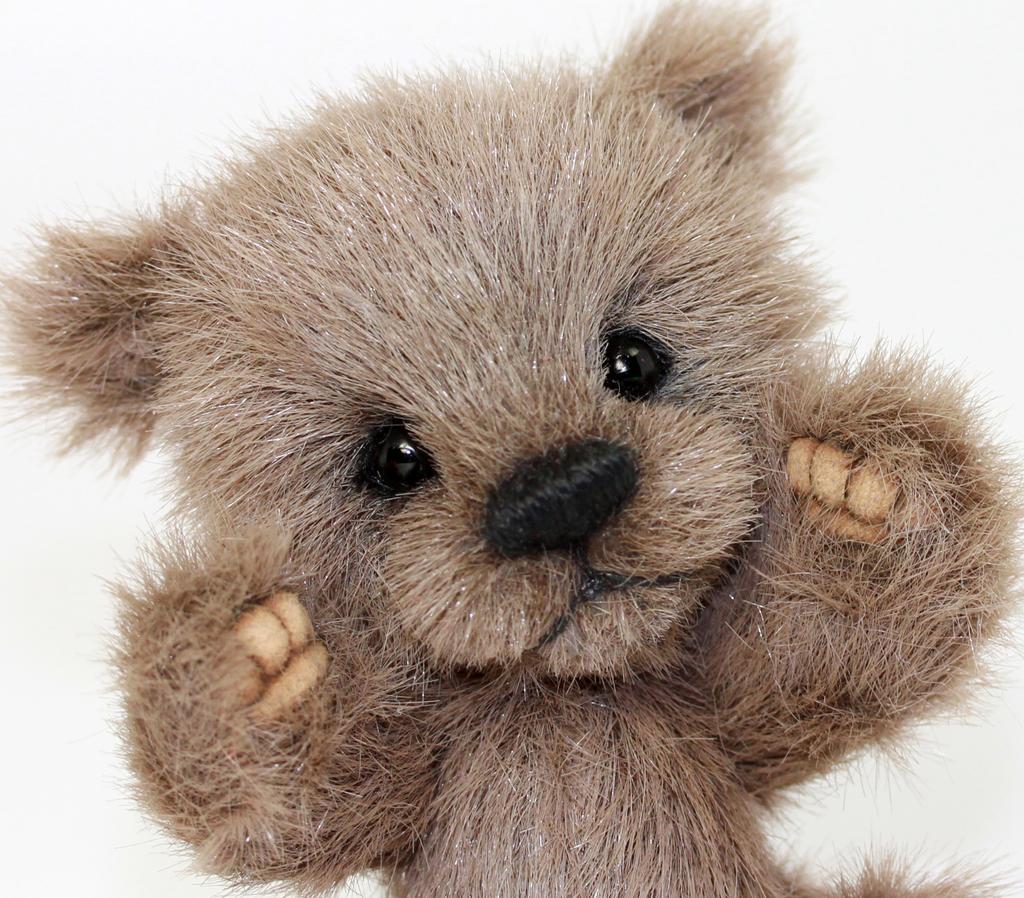Could you give a brief overview of what you see in this image? In this picture we can see a brown color small teddy bear toy. 